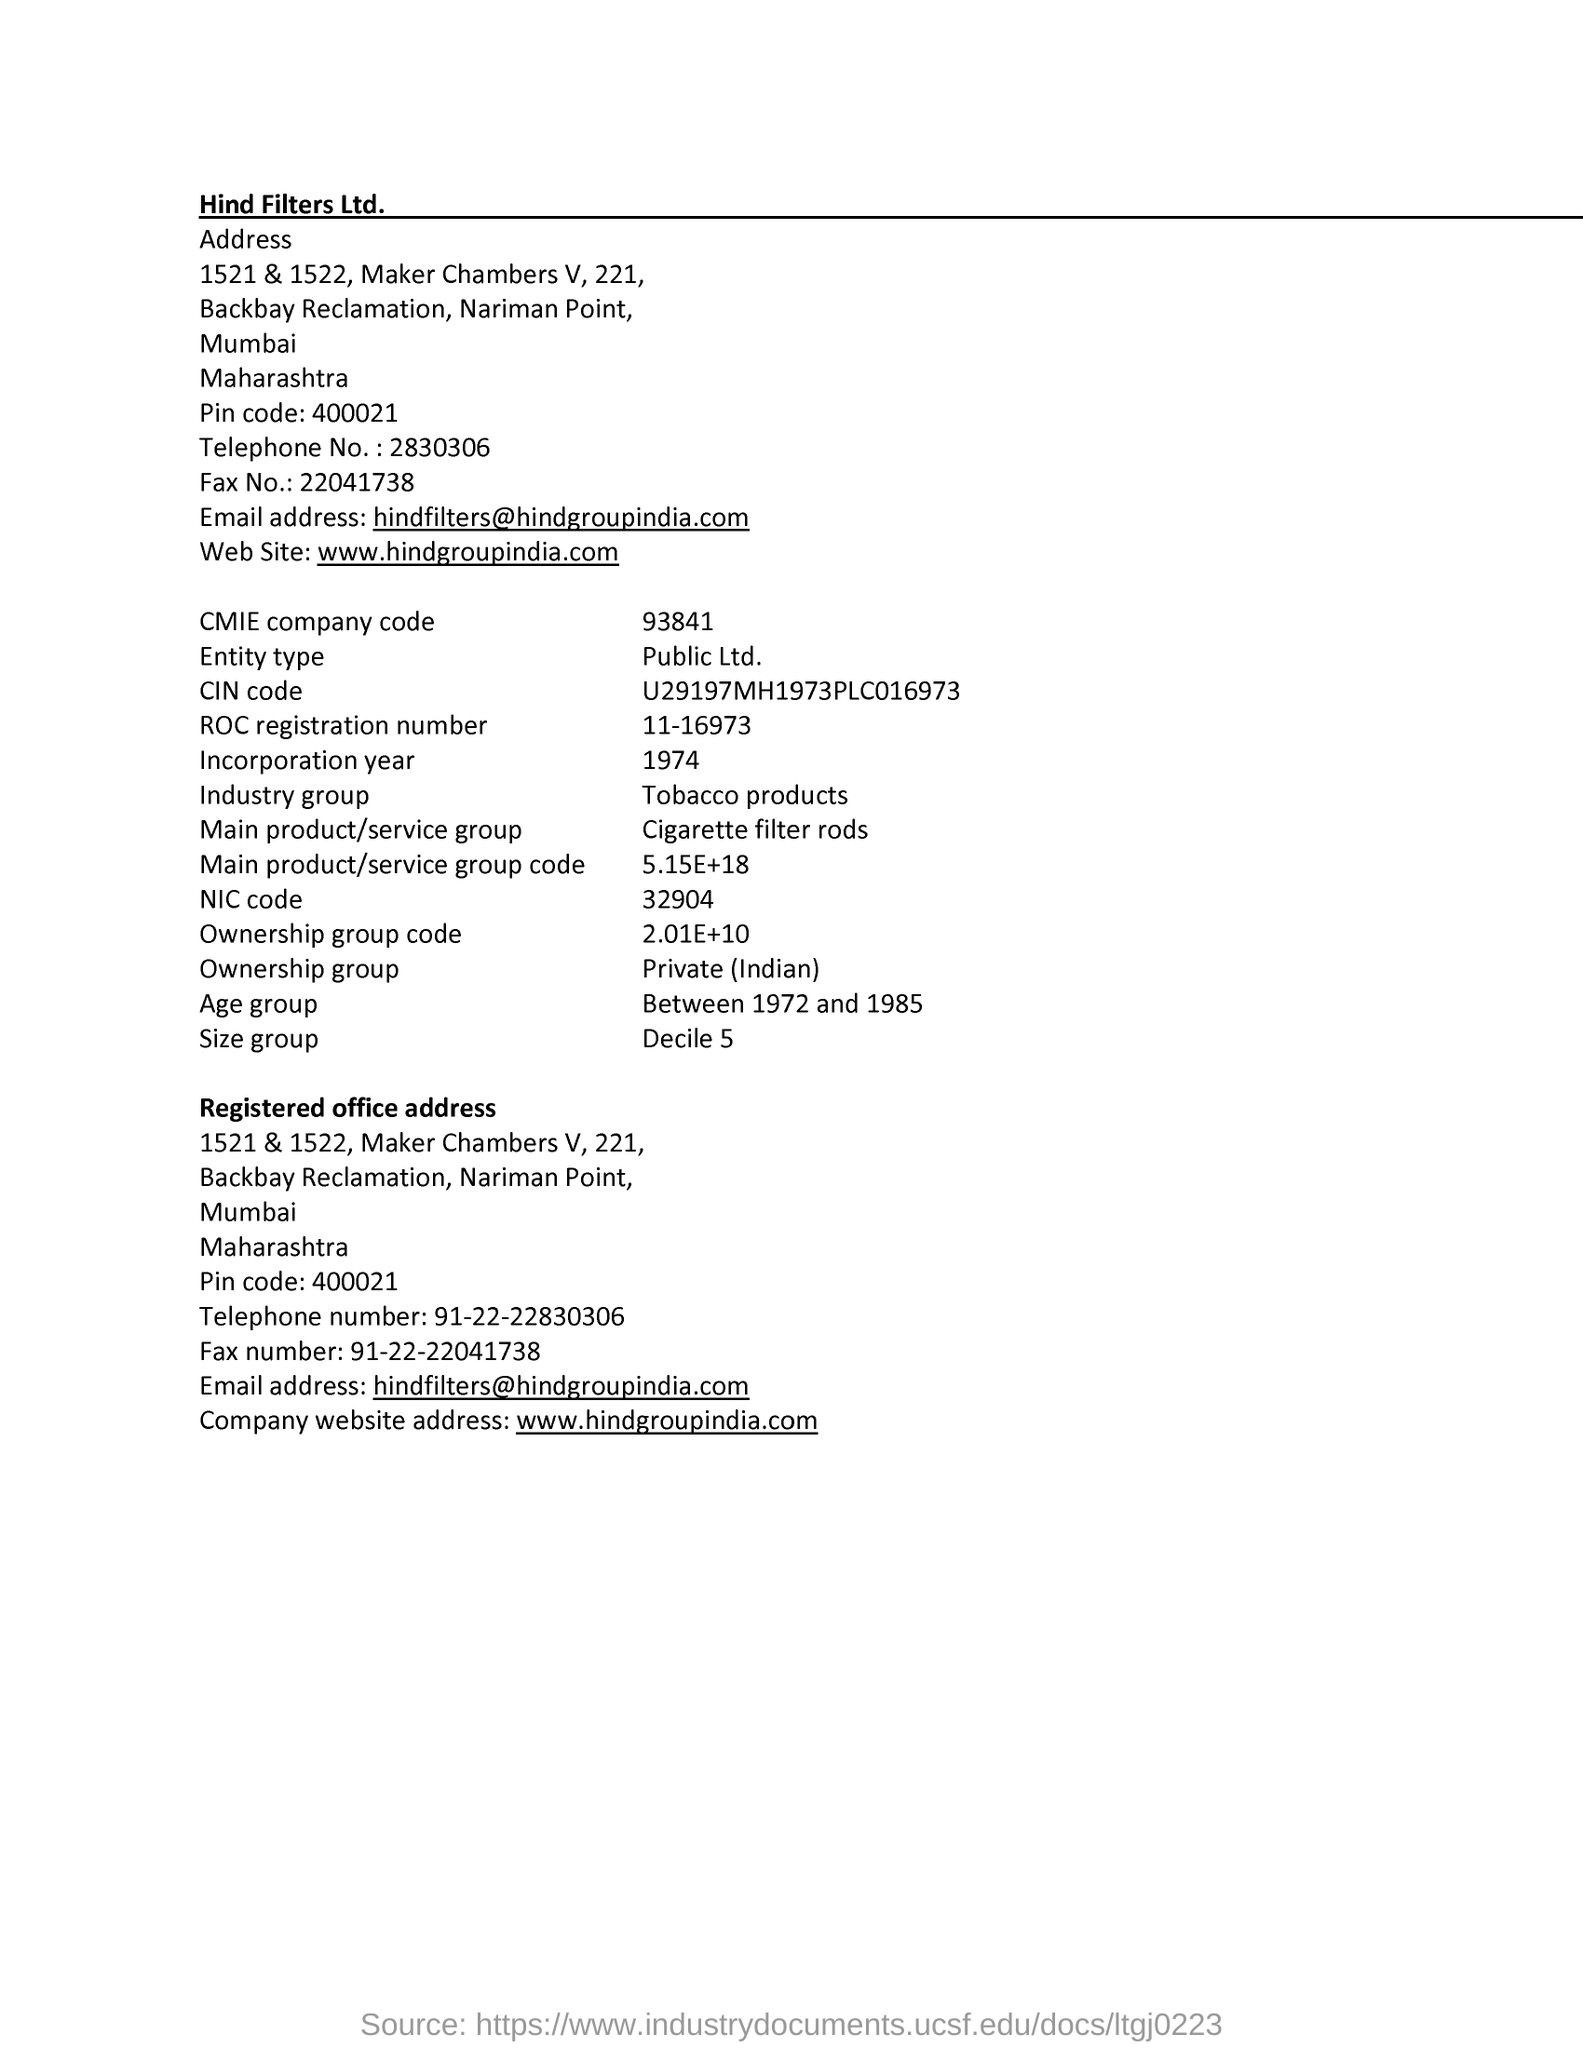What is size group?
Your response must be concise. Decile 5. What is NIC code?
Your answer should be very brief. 32904. What is incorporation year?
Give a very brief answer. 1974. What is tel. No?
Your response must be concise. 2830306. What is company's name?
Your answer should be compact. Hind Filters Ltd. 